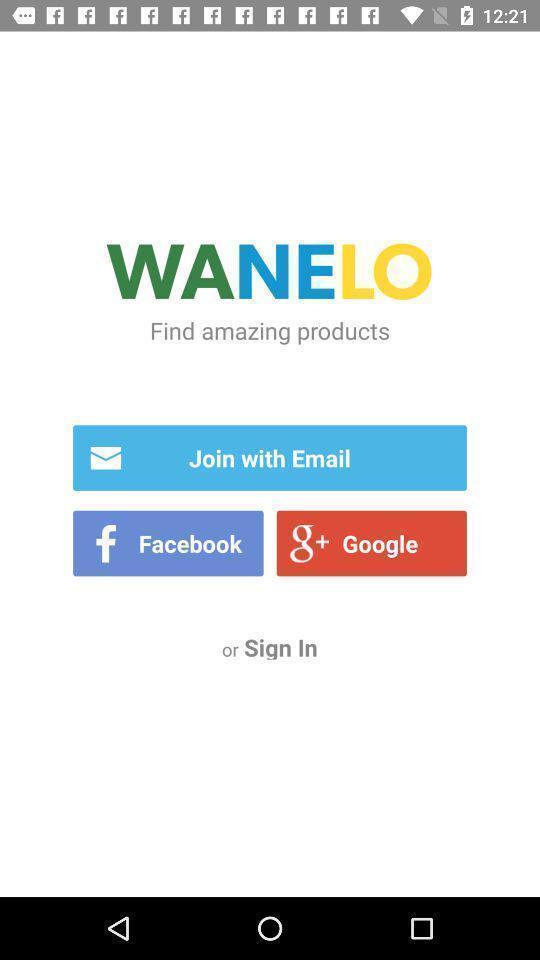What can you discern from this picture? Welcome page for a shopping application. 